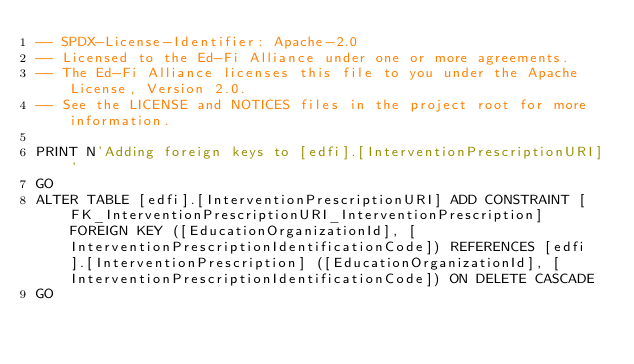<code> <loc_0><loc_0><loc_500><loc_500><_SQL_>-- SPDX-License-Identifier: Apache-2.0
-- Licensed to the Ed-Fi Alliance under one or more agreements.
-- The Ed-Fi Alliance licenses this file to you under the Apache License, Version 2.0.
-- See the LICENSE and NOTICES files in the project root for more information.

PRINT N'Adding foreign keys to [edfi].[InterventionPrescriptionURI]'
GO
ALTER TABLE [edfi].[InterventionPrescriptionURI] ADD CONSTRAINT [FK_InterventionPrescriptionURI_InterventionPrescription] FOREIGN KEY ([EducationOrganizationId], [InterventionPrescriptionIdentificationCode]) REFERENCES [edfi].[InterventionPrescription] ([EducationOrganizationId], [InterventionPrescriptionIdentificationCode]) ON DELETE CASCADE
GO
</code> 